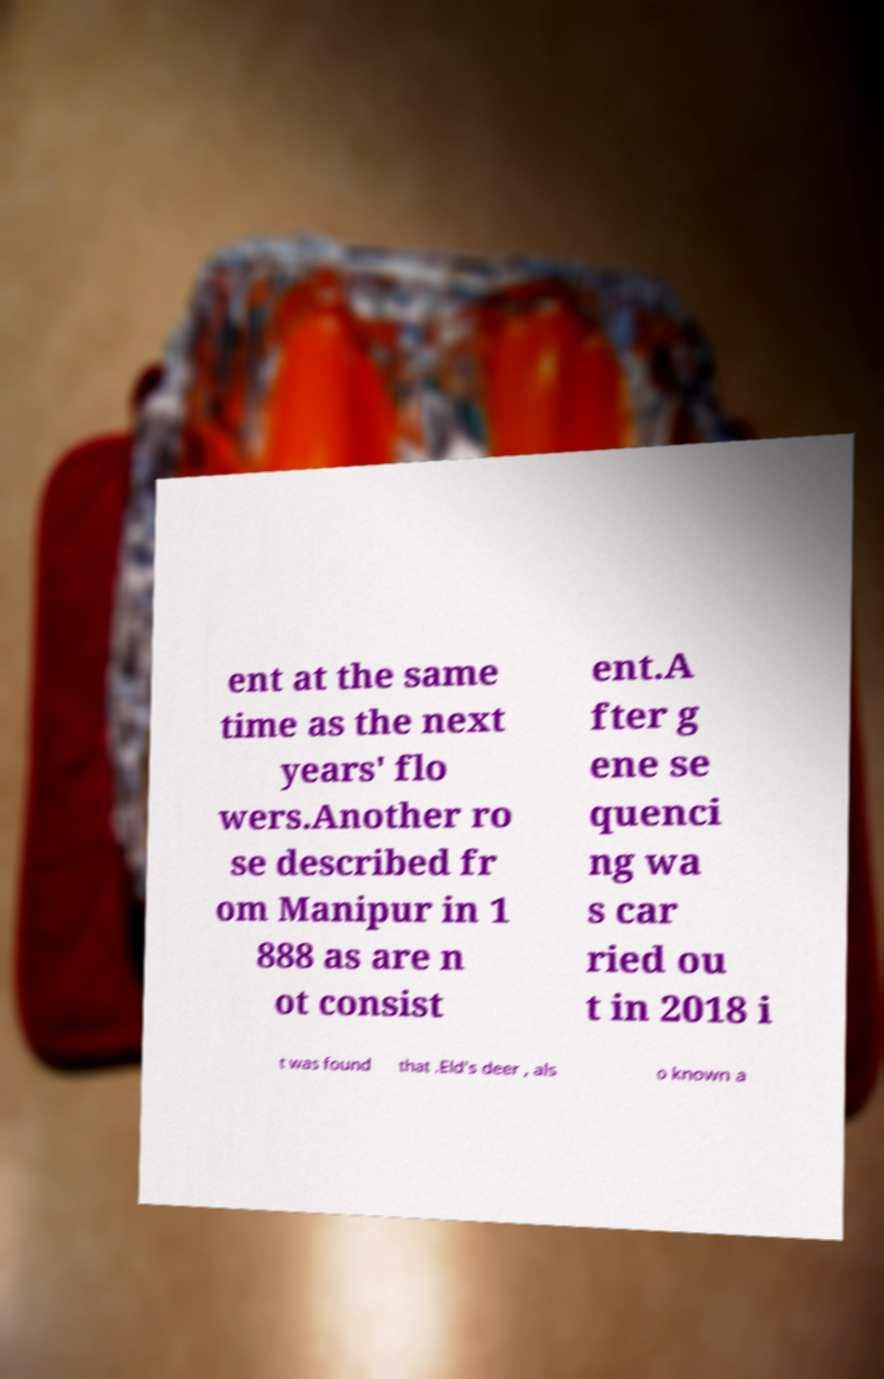I need the written content from this picture converted into text. Can you do that? ent at the same time as the next years' flo wers.Another ro se described fr om Manipur in 1 888 as are n ot consist ent.A fter g ene se quenci ng wa s car ried ou t in 2018 i t was found that .Eld's deer , als o known a 